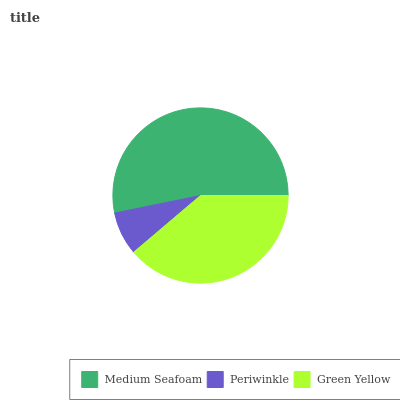Is Periwinkle the minimum?
Answer yes or no. Yes. Is Medium Seafoam the maximum?
Answer yes or no. Yes. Is Green Yellow the minimum?
Answer yes or no. No. Is Green Yellow the maximum?
Answer yes or no. No. Is Green Yellow greater than Periwinkle?
Answer yes or no. Yes. Is Periwinkle less than Green Yellow?
Answer yes or no. Yes. Is Periwinkle greater than Green Yellow?
Answer yes or no. No. Is Green Yellow less than Periwinkle?
Answer yes or no. No. Is Green Yellow the high median?
Answer yes or no. Yes. Is Green Yellow the low median?
Answer yes or no. Yes. Is Medium Seafoam the high median?
Answer yes or no. No. Is Periwinkle the low median?
Answer yes or no. No. 